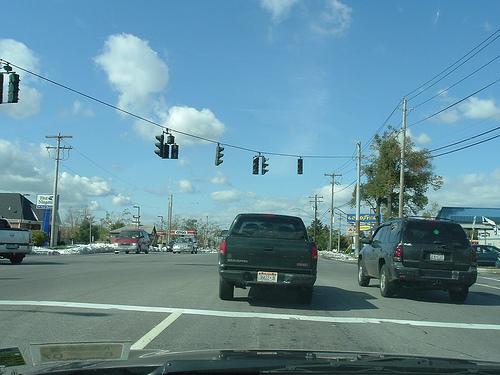How many cars are moving?
Write a very short answer. 4. What color is the truck?
Quick response, please. Black. What type of truck is this?
Be succinct. Pick up. What time of day is it?
Answer briefly. Daytime. How many vehicles are there?
Be succinct. 6. Does the black car have sliding doors?
Answer briefly. No. Is the truck moving?
Short answer required. Yes. 